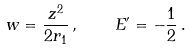Convert formula to latex. <formula><loc_0><loc_0><loc_500><loc_500>w = \frac { z ^ { 2 } } { 2 r _ { 1 } } \, , \quad E ^ { \prime } = - \frac { 1 } { 2 } \, .</formula> 